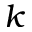<formula> <loc_0><loc_0><loc_500><loc_500>k</formula> 